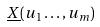Convert formula to latex. <formula><loc_0><loc_0><loc_500><loc_500>\underline { X } ( u _ { 1 } \dots , u _ { m } )</formula> 